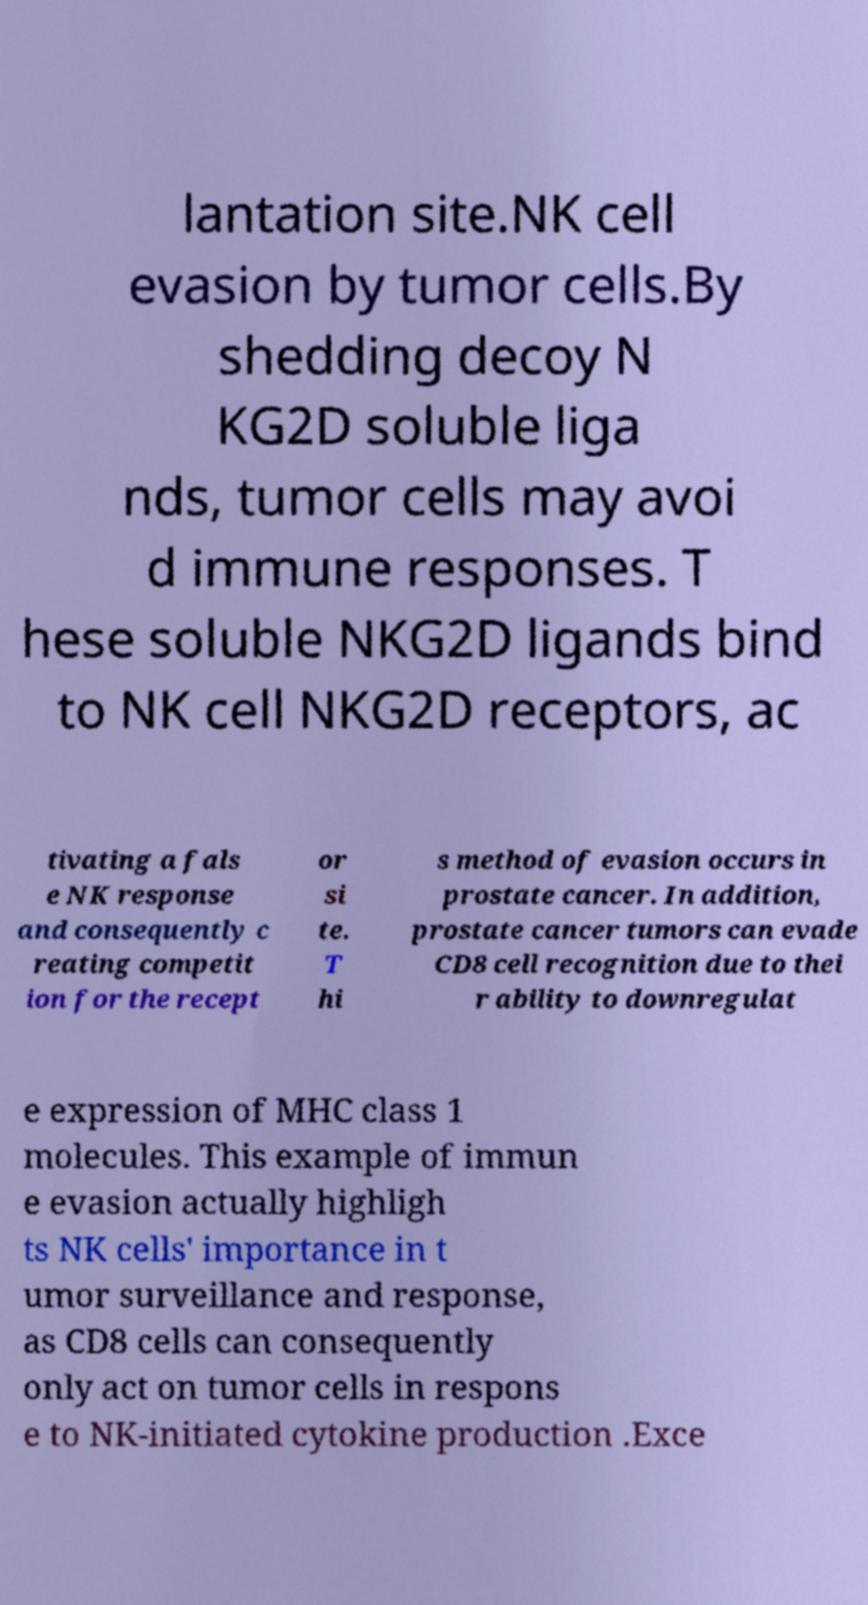Could you assist in decoding the text presented in this image and type it out clearly? lantation site.NK cell evasion by tumor cells.By shedding decoy N KG2D soluble liga nds, tumor cells may avoi d immune responses. T hese soluble NKG2D ligands bind to NK cell NKG2D receptors, ac tivating a fals e NK response and consequently c reating competit ion for the recept or si te. T hi s method of evasion occurs in prostate cancer. In addition, prostate cancer tumors can evade CD8 cell recognition due to thei r ability to downregulat e expression of MHC class 1 molecules. This example of immun e evasion actually highligh ts NK cells' importance in t umor surveillance and response, as CD8 cells can consequently only act on tumor cells in respons e to NK-initiated cytokine production .Exce 